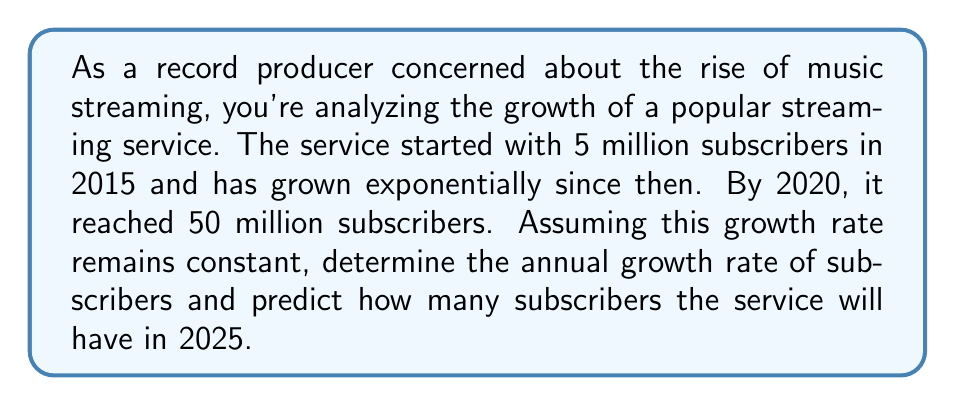Could you help me with this problem? To solve this problem, we'll use the exponential growth formula:

$$A = P(1 + r)^t$$

Where:
$A$ = Final amount
$P$ = Initial amount
$r$ = Annual growth rate (in decimal form)
$t$ = Time in years

We know:
$P = 5$ million (initial subscribers in 2015)
$A = 50$ million (subscribers in 2020)
$t = 5$ years (from 2015 to 2020)

Let's solve for $r$:

$$50 = 5(1 + r)^5$$

Divide both sides by 5:

$$10 = (1 + r)^5$$

Take the fifth root of both sides:

$$\sqrt[5]{10} = 1 + r$$

$$r = \sqrt[5]{10} - 1 \approx 0.5848 - 1 = 0.5848 - 1 = 0.5848$$

The annual growth rate is approximately 58.48%.

Now, to predict the number of subscribers in 2025, we use the same formula:

$$A = 50(1 + 0.5848)^5$$

$$A \approx 50 \cdot 10.0889 \approx 504.445$$
Answer: The annual growth rate is approximately 58.48%, and the predicted number of subscribers in 2025 is approximately 504.4 million. 